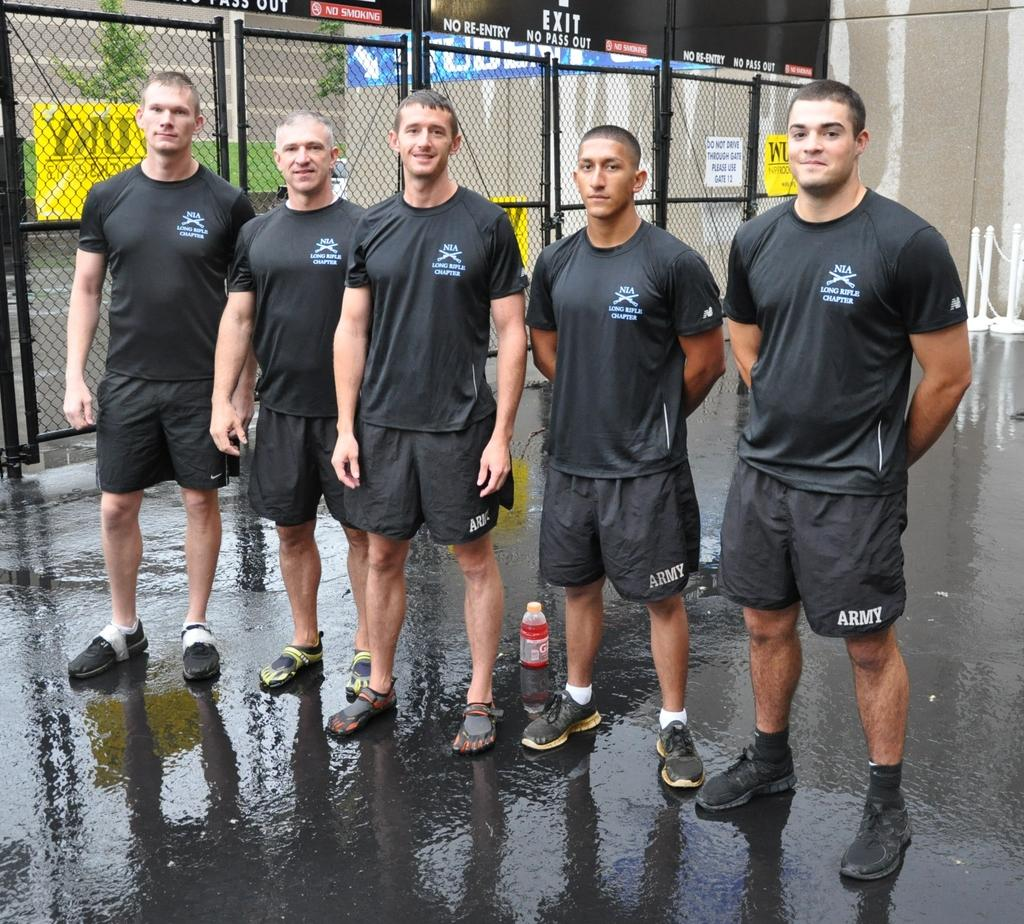How many people are present in the image? There are five people standing in the image. What are the people wearing? The people are wearing black shirts and trousers. What can be seen in the image besides the people? There is a fence, plants, a banner, and buildings in the background of the image. What type of tax is being discussed on the banner in the image? There is no mention of tax on the banner in the image. What shape is the love depicted in the image? There is no depiction of love in the image. 